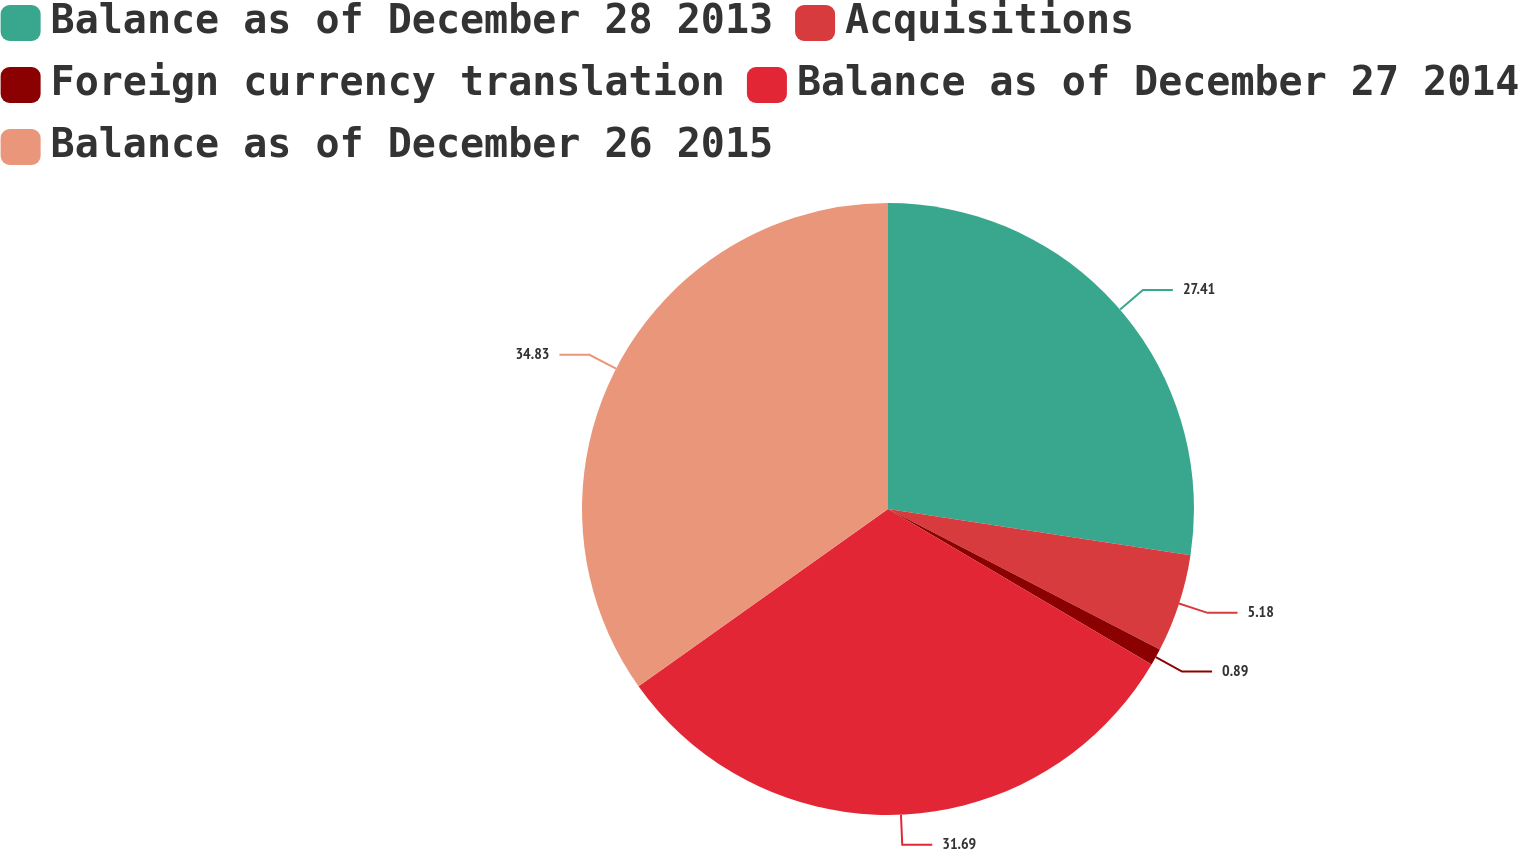Convert chart. <chart><loc_0><loc_0><loc_500><loc_500><pie_chart><fcel>Balance as of December 28 2013<fcel>Acquisitions<fcel>Foreign currency translation<fcel>Balance as of December 27 2014<fcel>Balance as of December 26 2015<nl><fcel>27.41%<fcel>5.18%<fcel>0.89%<fcel>31.69%<fcel>34.83%<nl></chart> 